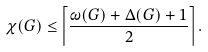Convert formula to latex. <formula><loc_0><loc_0><loc_500><loc_500>\chi ( G ) \leq \left \lceil { \frac { \omega ( G ) + \Delta ( G ) + 1 } { 2 } } \right \rceil .</formula> 